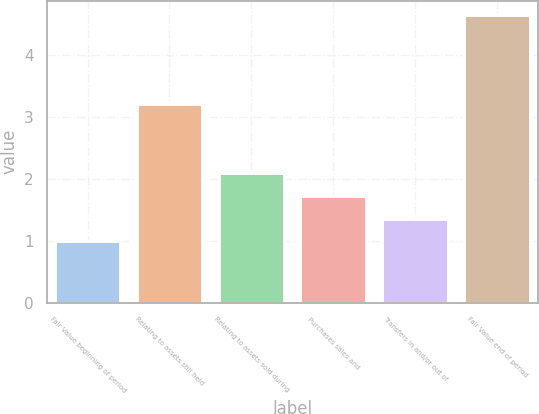Convert chart to OTSL. <chart><loc_0><loc_0><loc_500><loc_500><bar_chart><fcel>Fair Value beginning of period<fcel>Relating to assets still held<fcel>Relating to assets sold during<fcel>Purchases sales and<fcel>Transfers in and/or out of<fcel>Fair Value end of period<nl><fcel>1<fcel>3.21<fcel>2.1<fcel>1.73<fcel>1.36<fcel>4.65<nl></chart> 